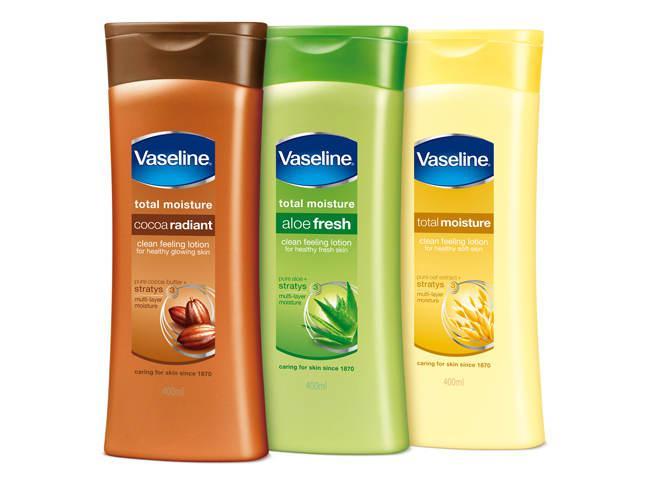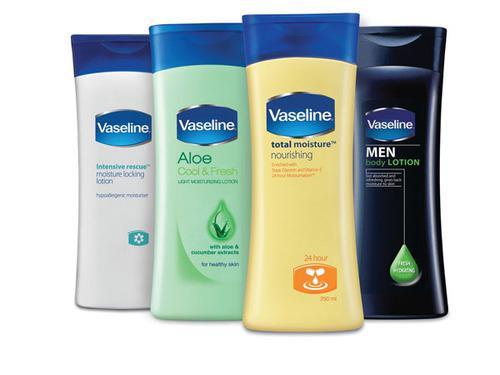The first image is the image on the left, the second image is the image on the right. For the images displayed, is the sentence "Each image contains at least three skincare products." factually correct? Answer yes or no. Yes. The first image is the image on the left, the second image is the image on the right. Analyze the images presented: Is the assertion "Each image shows at least three plastic bottles of a product in different colors." valid? Answer yes or no. Yes. 